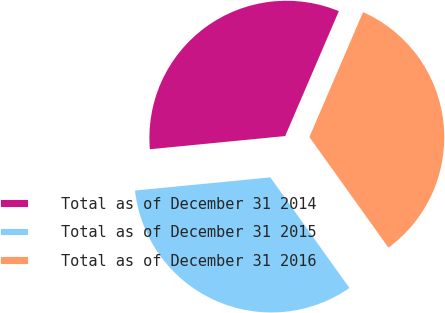<chart> <loc_0><loc_0><loc_500><loc_500><pie_chart><fcel>Total as of December 31 2014<fcel>Total as of December 31 2015<fcel>Total as of December 31 2016<nl><fcel>33.0%<fcel>33.33%<fcel>33.66%<nl></chart> 